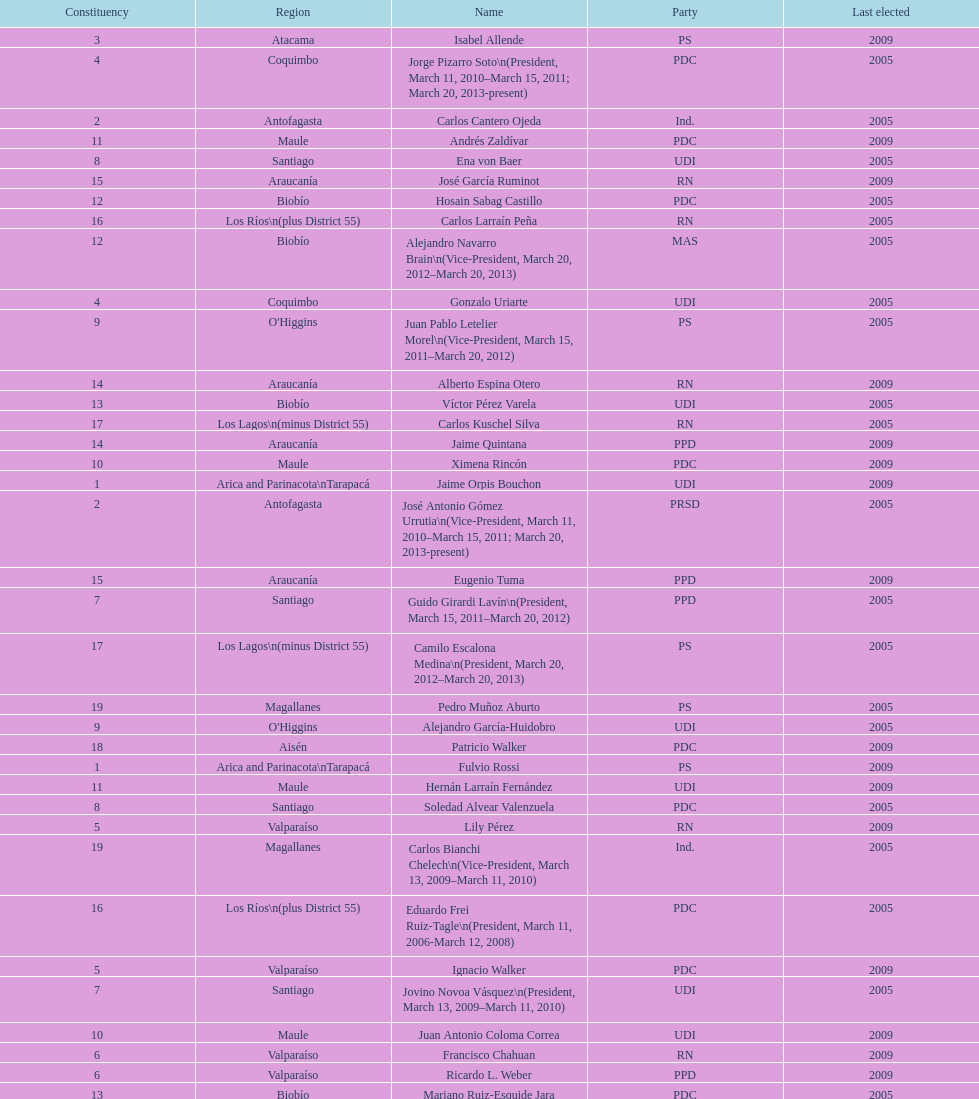Parse the full table. {'header': ['Constituency', 'Region', 'Name', 'Party', 'Last elected'], 'rows': [['3', 'Atacama', 'Isabel Allende', 'PS', '2009'], ['4', 'Coquimbo', 'Jorge Pizarro Soto\\n(President, March 11, 2010–March 15, 2011; March 20, 2013-present)', 'PDC', '2005'], ['2', 'Antofagasta', 'Carlos Cantero Ojeda', 'Ind.', '2005'], ['11', 'Maule', 'Andrés Zaldívar', 'PDC', '2009'], ['8', 'Santiago', 'Ena von Baer', 'UDI', '2005'], ['15', 'Araucanía', 'José García Ruminot', 'RN', '2009'], ['12', 'Biobío', 'Hosain Sabag Castillo', 'PDC', '2005'], ['16', 'Los Ríos\\n(plus District 55)', 'Carlos Larraín Peña', 'RN', '2005'], ['12', 'Biobío', 'Alejandro Navarro Brain\\n(Vice-President, March 20, 2012–March 20, 2013)', 'MAS', '2005'], ['4', 'Coquimbo', 'Gonzalo Uriarte', 'UDI', '2005'], ['9', "O'Higgins", 'Juan Pablo Letelier Morel\\n(Vice-President, March 15, 2011–March 20, 2012)', 'PS', '2005'], ['14', 'Araucanía', 'Alberto Espina Otero', 'RN', '2009'], ['13', 'Biobío', 'Víctor Pérez Varela', 'UDI', '2005'], ['17', 'Los Lagos\\n(minus District 55)', 'Carlos Kuschel Silva', 'RN', '2005'], ['14', 'Araucanía', 'Jaime Quintana', 'PPD', '2009'], ['10', 'Maule', 'Ximena Rincón', 'PDC', '2009'], ['1', 'Arica and Parinacota\\nTarapacá', 'Jaime Orpis Bouchon', 'UDI', '2009'], ['2', 'Antofagasta', 'José Antonio Gómez Urrutia\\n(Vice-President, March 11, 2010–March 15, 2011; March 20, 2013-present)', 'PRSD', '2005'], ['15', 'Araucanía', 'Eugenio Tuma', 'PPD', '2009'], ['7', 'Santiago', 'Guido Girardi Lavín\\n(President, March 15, 2011–March 20, 2012)', 'PPD', '2005'], ['17', 'Los Lagos\\n(minus District 55)', 'Camilo Escalona Medina\\n(President, March 20, 2012–March 20, 2013)', 'PS', '2005'], ['19', 'Magallanes', 'Pedro Muñoz Aburto', 'PS', '2005'], ['9', "O'Higgins", 'Alejandro García-Huidobro', 'UDI', '2005'], ['18', 'Aisén', 'Patricio Walker', 'PDC', '2009'], ['1', 'Arica and Parinacota\\nTarapacá', 'Fulvio Rossi', 'PS', '2009'], ['11', 'Maule', 'Hernán Larraín Fernández', 'UDI', '2009'], ['8', 'Santiago', 'Soledad Alvear Valenzuela', 'PDC', '2005'], ['5', 'Valparaíso', 'Lily Pérez', 'RN', '2009'], ['19', 'Magallanes', 'Carlos Bianchi Chelech\\n(Vice-President, March 13, 2009–March 11, 2010)', 'Ind.', '2005'], ['16', 'Los Ríos\\n(plus District 55)', 'Eduardo Frei Ruiz-Tagle\\n(President, March 11, 2006-March 12, 2008)', 'PDC', '2005'], ['5', 'Valparaíso', 'Ignacio Walker', 'PDC', '2009'], ['7', 'Santiago', 'Jovino Novoa Vásquez\\n(President, March 13, 2009–March 11, 2010)', 'UDI', '2005'], ['10', 'Maule', 'Juan Antonio Coloma Correa', 'UDI', '2009'], ['6', 'Valparaíso', 'Francisco Chahuan', 'RN', '2009'], ['6', 'Valparaíso', 'Ricardo L. Weber', 'PPD', '2009'], ['13', 'Biobío', 'Mariano Ruiz-Esquide Jara', 'PDC', '2005'], ['18', 'Aisén', 'Antonio Horvath Kiss', 'RN', '2001'], ['3', 'Atacama', 'Baldo Prokurica Prokurica\\n(Vice-President, March 12, 2008-March 13, 2009)', 'RN', '2009']]} What is the first name on the table? Fulvio Rossi. 